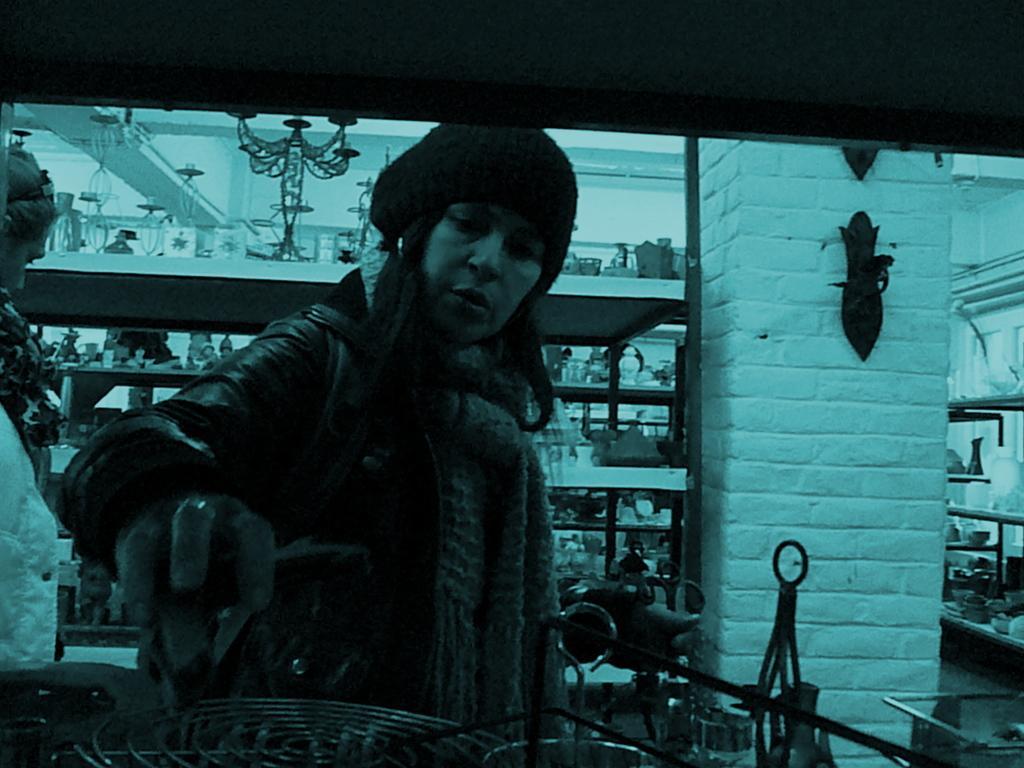Could you give a brief overview of what you see in this image? This picture seems to be clicked inside. On the left corner there is a person seems to be standing on the ground and there is another person wearing jacket, holding some object and standing on the ground. In the foreground there are some objects. In the background there is a wall, cabinets containing many number of objects. 